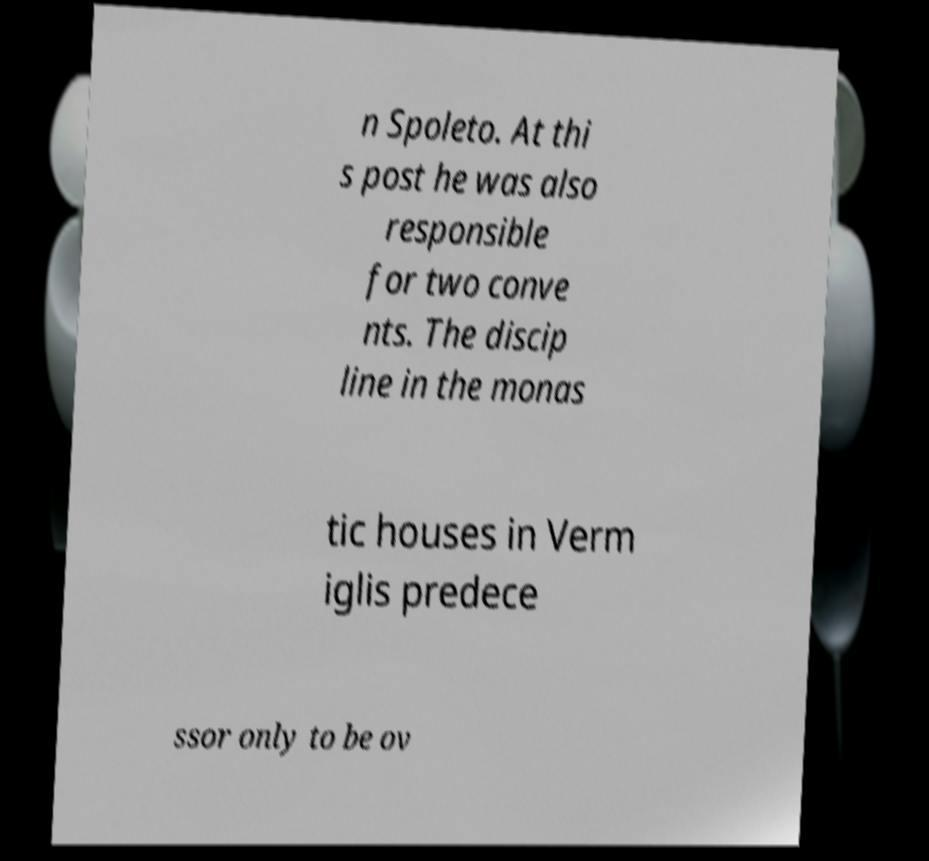There's text embedded in this image that I need extracted. Can you transcribe it verbatim? n Spoleto. At thi s post he was also responsible for two conve nts. The discip line in the monas tic houses in Verm iglis predece ssor only to be ov 